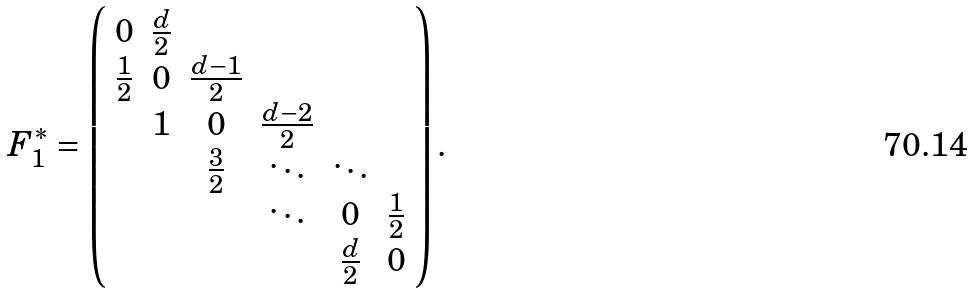Convert formula to latex. <formula><loc_0><loc_0><loc_500><loc_500>F _ { 1 } ^ { * } = \left ( \begin{array} { c c c c c c c c } 0 & \frac { d } 2 \\ \frac { 1 } { 2 } & 0 & \frac { d - 1 } 2 \\ & 1 & 0 & \frac { d - 2 } 2 \\ & & \frac { 3 } { 2 } & \ddots & \ddots \\ & & & \ddots & 0 & \frac { 1 } { 2 } \\ & & & & \frac { d } 2 & 0 \end{array} \right ) .</formula> 